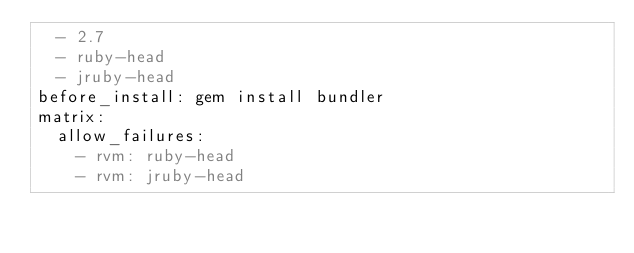<code> <loc_0><loc_0><loc_500><loc_500><_YAML_>  - 2.7
  - ruby-head
  - jruby-head
before_install: gem install bundler
matrix:
  allow_failures:
    - rvm: ruby-head
    - rvm: jruby-head
</code> 